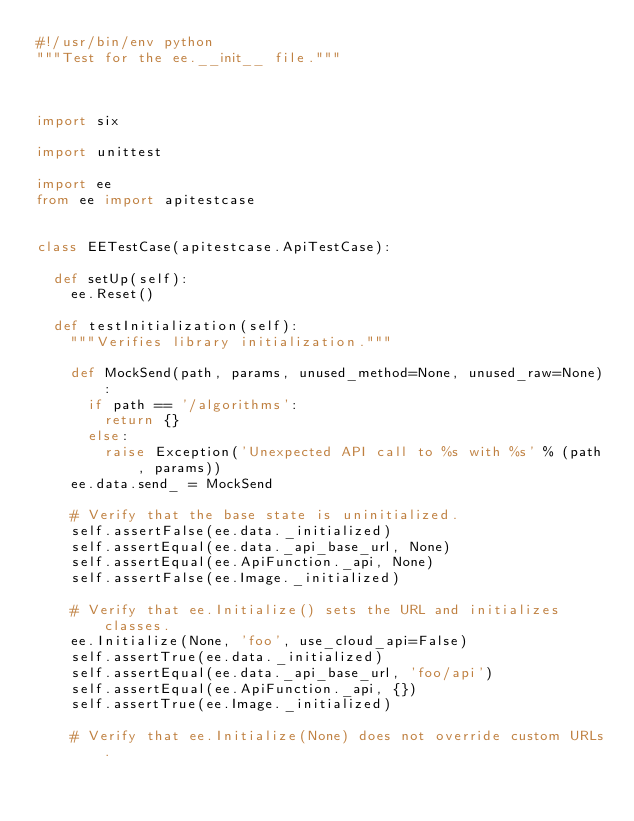Convert code to text. <code><loc_0><loc_0><loc_500><loc_500><_Python_>#!/usr/bin/env python
"""Test for the ee.__init__ file."""



import six

import unittest

import ee
from ee import apitestcase


class EETestCase(apitestcase.ApiTestCase):

  def setUp(self):
    ee.Reset()

  def testInitialization(self):
    """Verifies library initialization."""

    def MockSend(path, params, unused_method=None, unused_raw=None):
      if path == '/algorithms':
        return {}
      else:
        raise Exception('Unexpected API call to %s with %s' % (path, params))
    ee.data.send_ = MockSend

    # Verify that the base state is uninitialized.
    self.assertFalse(ee.data._initialized)
    self.assertEqual(ee.data._api_base_url, None)
    self.assertEqual(ee.ApiFunction._api, None)
    self.assertFalse(ee.Image._initialized)

    # Verify that ee.Initialize() sets the URL and initializes classes.
    ee.Initialize(None, 'foo', use_cloud_api=False)
    self.assertTrue(ee.data._initialized)
    self.assertEqual(ee.data._api_base_url, 'foo/api')
    self.assertEqual(ee.ApiFunction._api, {})
    self.assertTrue(ee.Image._initialized)

    # Verify that ee.Initialize(None) does not override custom URLs.</code> 